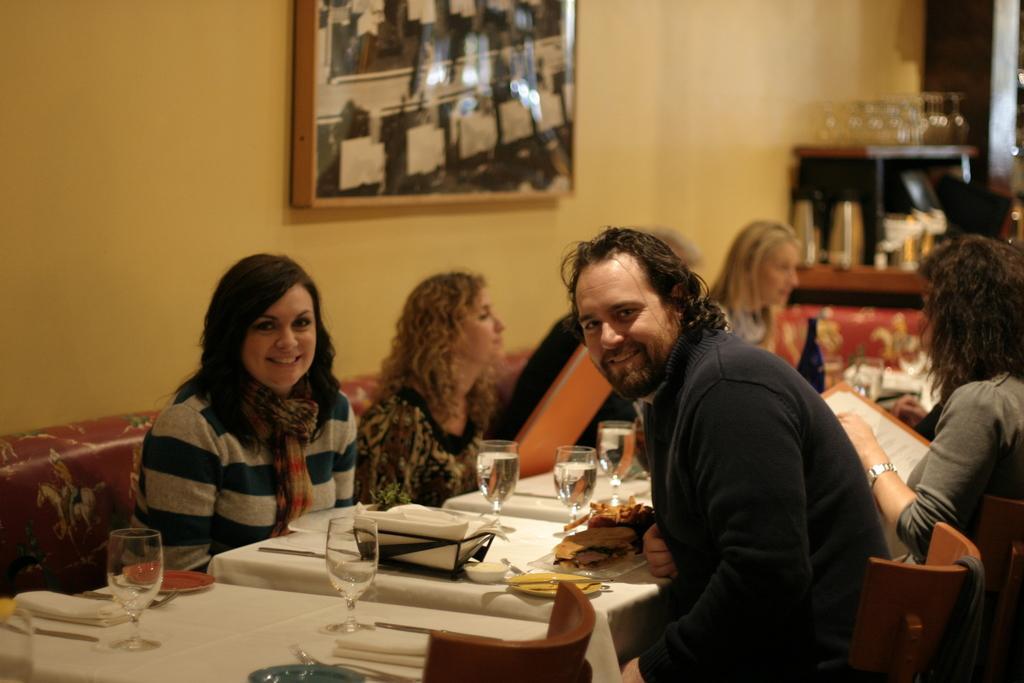Can you describe this image briefly? In this picture we can see four woman and one man sitting on chairs and in front of them on table we have glasses with water in it, tissue papers, spoons, fork, bowl and here woman and man are smiling and in the background we can see wall, frame, box. 